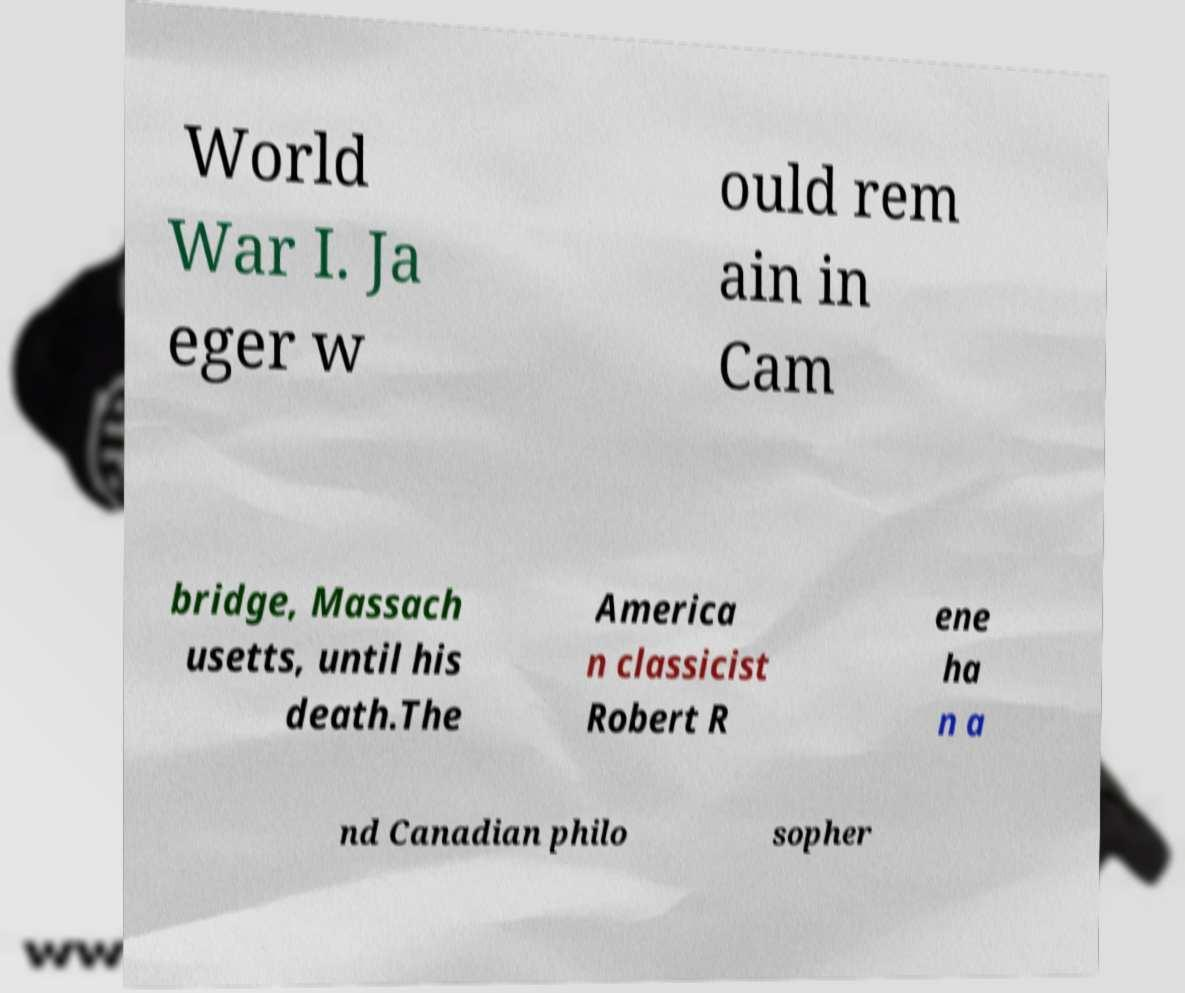There's text embedded in this image that I need extracted. Can you transcribe it verbatim? World War I. Ja eger w ould rem ain in Cam bridge, Massach usetts, until his death.The America n classicist Robert R ene ha n a nd Canadian philo sopher 